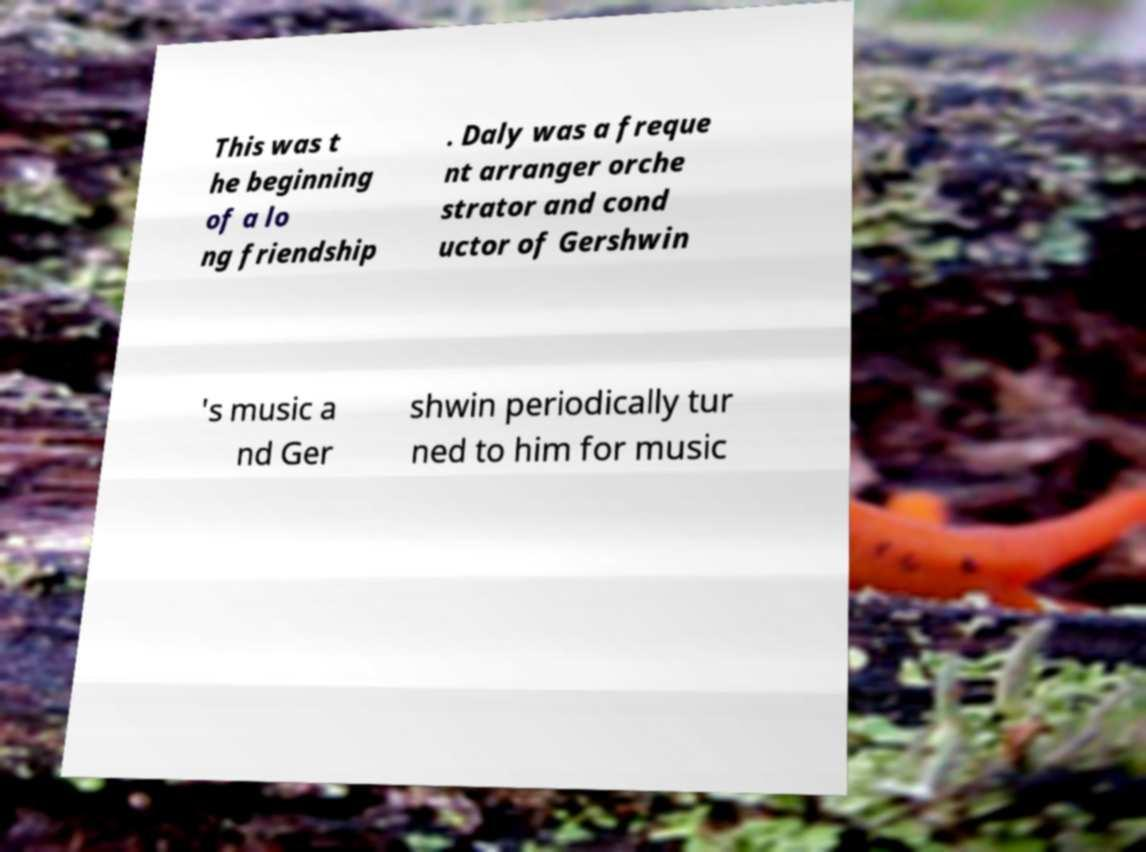Please identify and transcribe the text found in this image. This was t he beginning of a lo ng friendship . Daly was a freque nt arranger orche strator and cond uctor of Gershwin 's music a nd Ger shwin periodically tur ned to him for music 